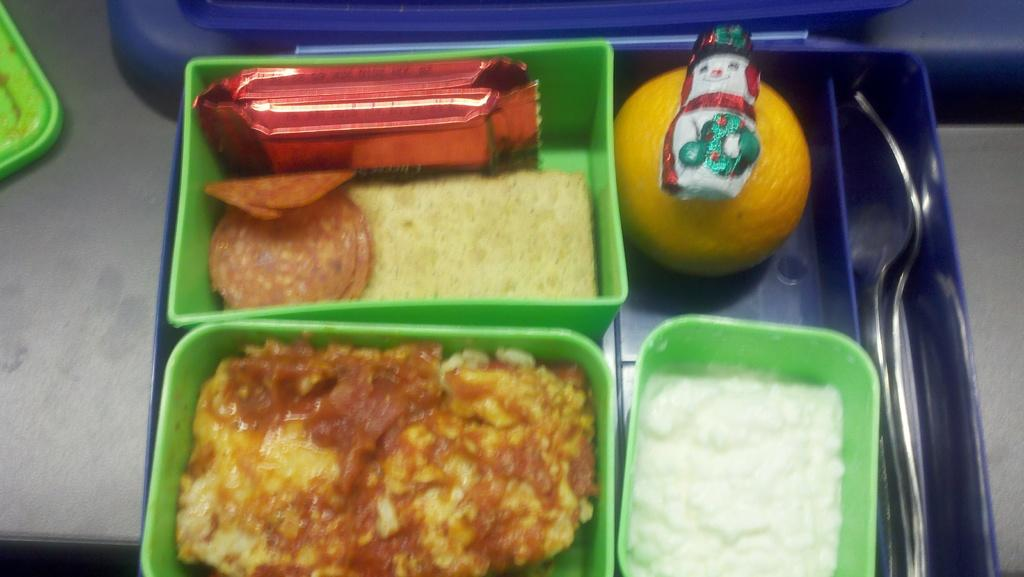What objects are in the foreground of the picture? There are plastic boxes, spoons, food items, fruit, and packets in the foreground of the picture. What type of utensils can be seen in the foreground? Spoons can be seen in the foreground of the picture. What kind of food items are visible in the foreground? Food items and fruit are visible in the foreground of the picture. What is the surface on which these items are placed? There is a table at the bottom of the picture. Can you see any branches in the picture? There are no branches visible in the picture. How do the food items express disgust in the picture? The food items do not express any emotions, including disgust, in the picture. 